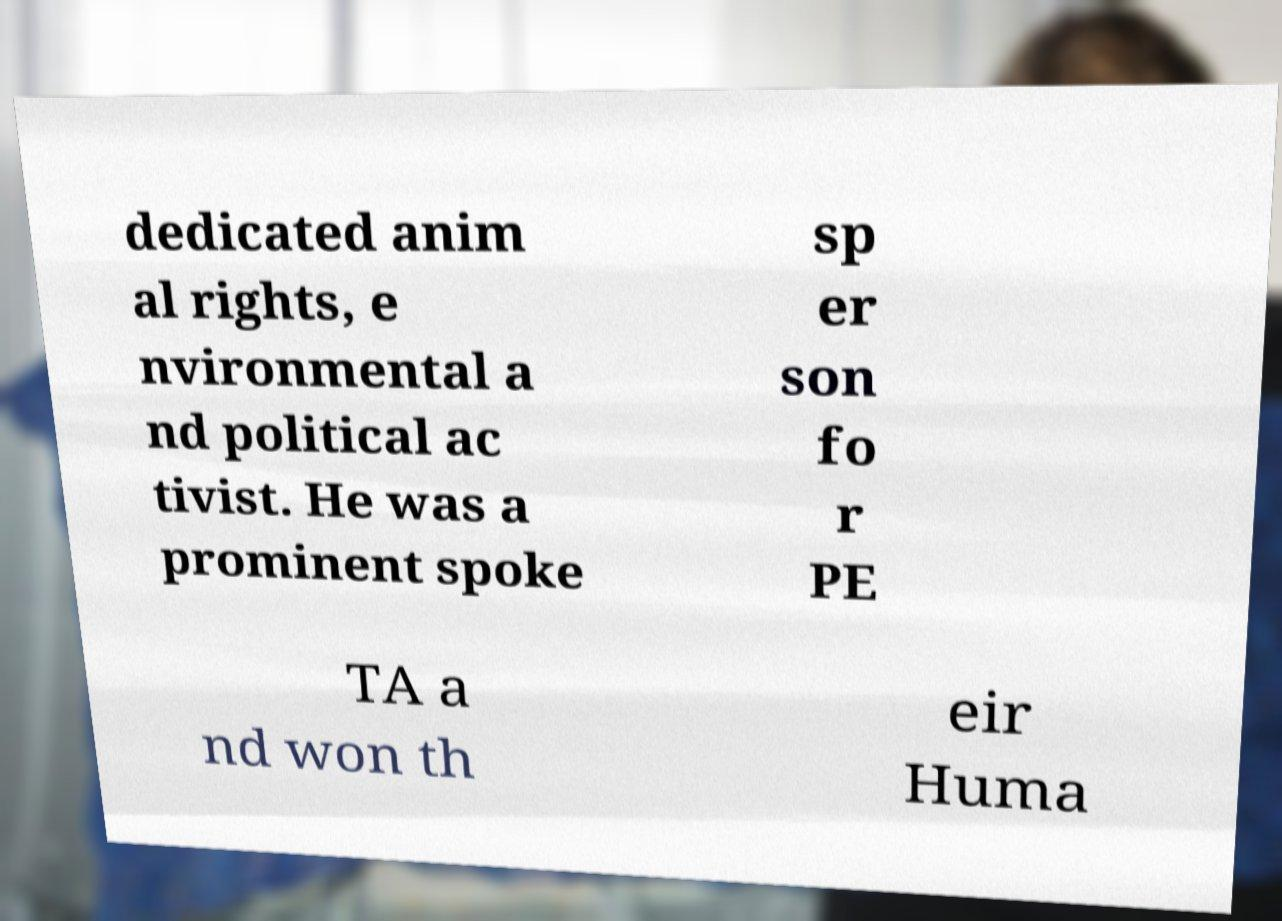Please identify and transcribe the text found in this image. dedicated anim al rights, e nvironmental a nd political ac tivist. He was a prominent spoke sp er son fo r PE TA a nd won th eir Huma 